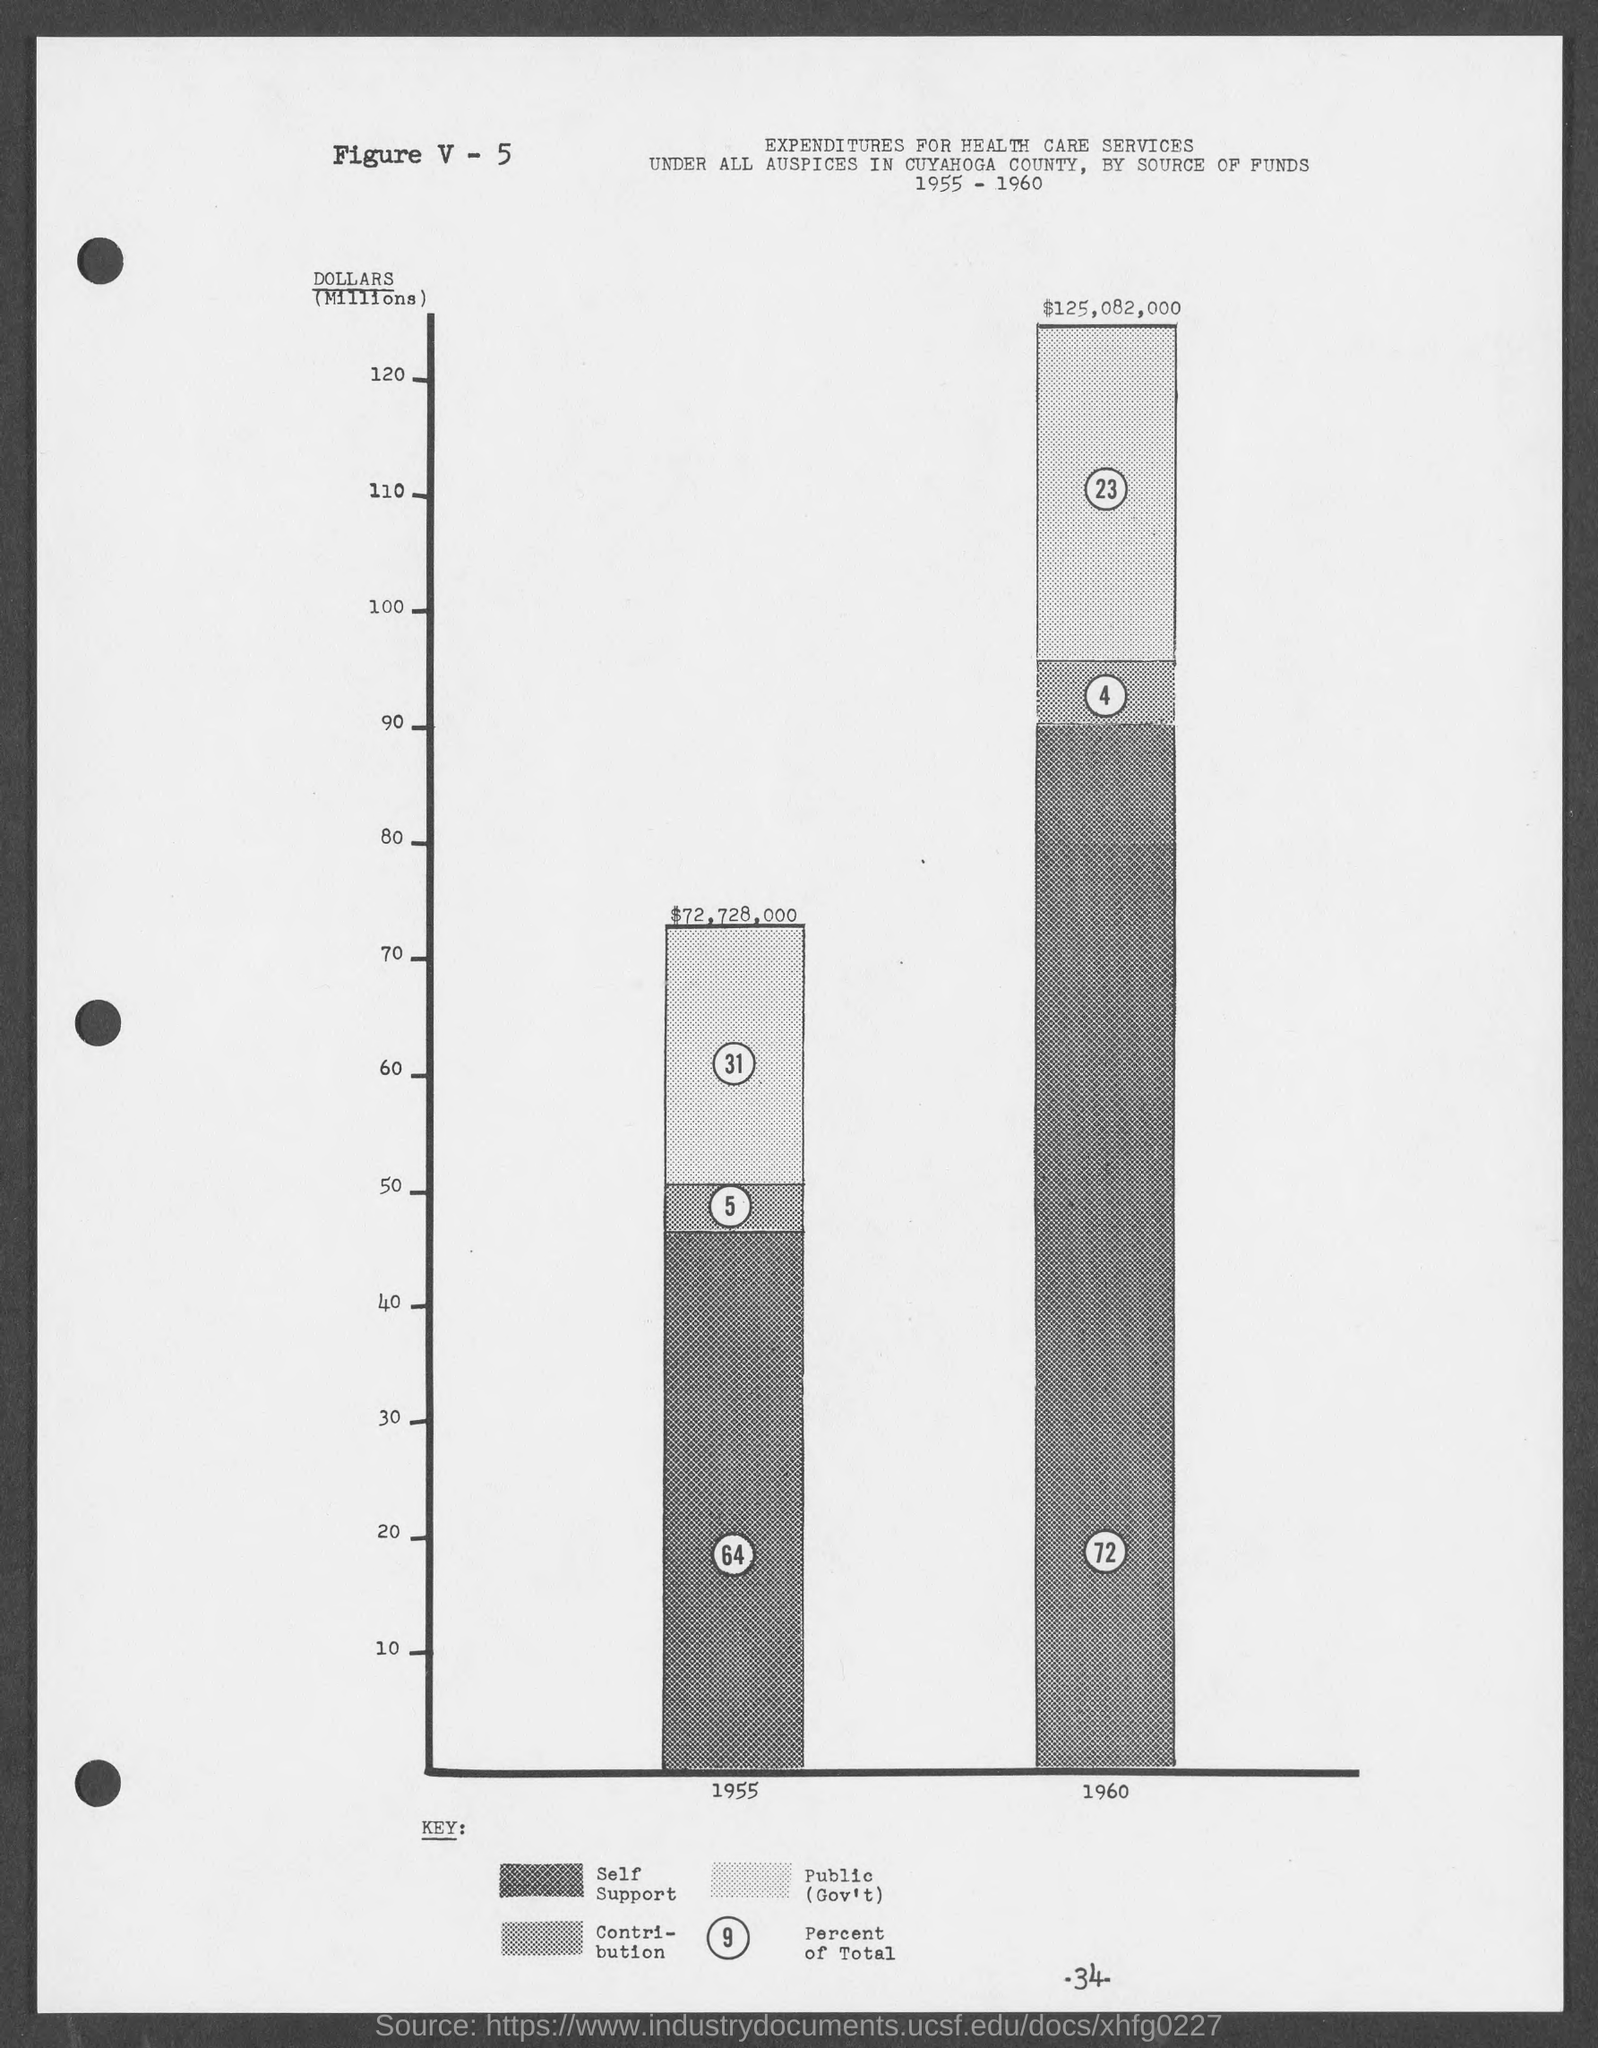What is the figure no.?
Your answer should be very brief. V - 5. What is the number at bottom of the page ?
Your response must be concise. -34-. 